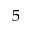<formula> <loc_0><loc_0><loc_500><loc_500>5</formula> 